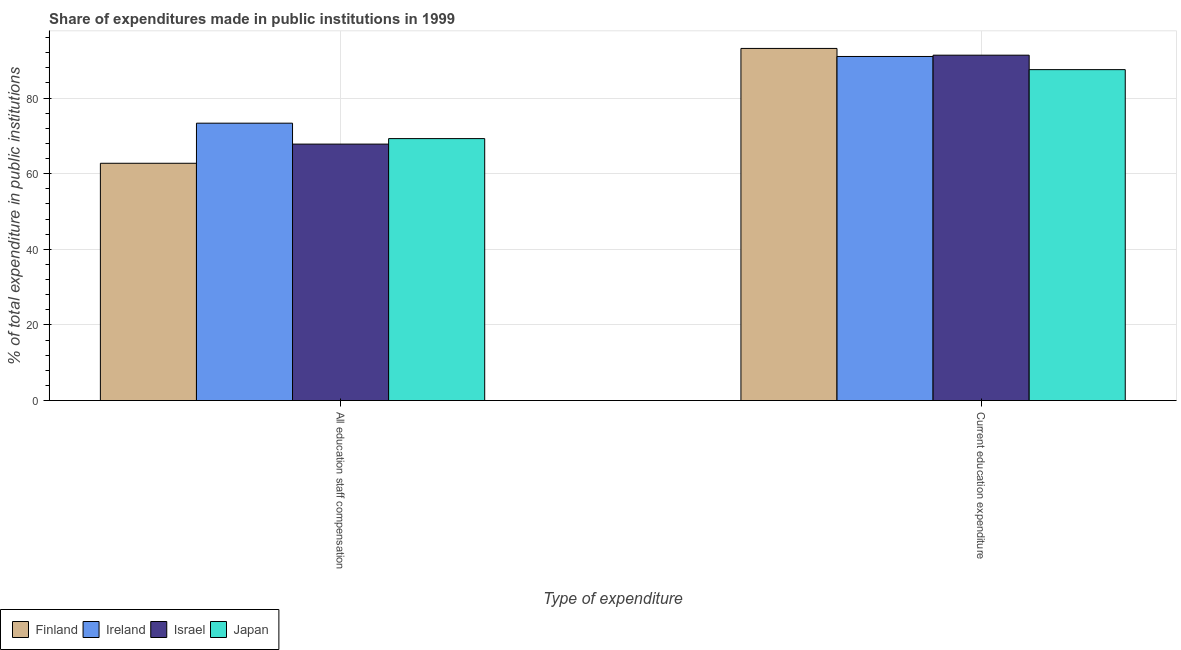Are the number of bars on each tick of the X-axis equal?
Make the answer very short. Yes. How many bars are there on the 2nd tick from the right?
Offer a very short reply. 4. What is the label of the 1st group of bars from the left?
Offer a terse response. All education staff compensation. What is the expenditure in education in Ireland?
Provide a succinct answer. 90.98. Across all countries, what is the maximum expenditure in staff compensation?
Your answer should be compact. 73.35. Across all countries, what is the minimum expenditure in staff compensation?
Offer a very short reply. 62.74. In which country was the expenditure in staff compensation maximum?
Offer a very short reply. Ireland. What is the total expenditure in staff compensation in the graph?
Offer a very short reply. 273.17. What is the difference between the expenditure in staff compensation in Ireland and that in Japan?
Your answer should be very brief. 4.08. What is the difference between the expenditure in staff compensation in Finland and the expenditure in education in Ireland?
Ensure brevity in your answer.  -28.24. What is the average expenditure in education per country?
Provide a succinct answer. 90.73. What is the difference between the expenditure in education and expenditure in staff compensation in Finland?
Offer a terse response. 30.37. In how many countries, is the expenditure in staff compensation greater than 24 %?
Offer a very short reply. 4. What is the ratio of the expenditure in staff compensation in Finland to that in Israel?
Ensure brevity in your answer.  0.93. Is the expenditure in staff compensation in Israel less than that in Ireland?
Your answer should be compact. Yes. In how many countries, is the expenditure in education greater than the average expenditure in education taken over all countries?
Offer a very short reply. 3. What does the 1st bar from the right in Current education expenditure represents?
Offer a very short reply. Japan. How many bars are there?
Ensure brevity in your answer.  8. Are all the bars in the graph horizontal?
Your response must be concise. No. How many countries are there in the graph?
Offer a terse response. 4. What is the difference between two consecutive major ticks on the Y-axis?
Keep it short and to the point. 20. Are the values on the major ticks of Y-axis written in scientific E-notation?
Your response must be concise. No. How are the legend labels stacked?
Provide a succinct answer. Horizontal. What is the title of the graph?
Ensure brevity in your answer.  Share of expenditures made in public institutions in 1999. Does "Timor-Leste" appear as one of the legend labels in the graph?
Offer a very short reply. No. What is the label or title of the X-axis?
Offer a very short reply. Type of expenditure. What is the label or title of the Y-axis?
Make the answer very short. % of total expenditure in public institutions. What is the % of total expenditure in public institutions in Finland in All education staff compensation?
Your answer should be compact. 62.74. What is the % of total expenditure in public institutions of Ireland in All education staff compensation?
Your answer should be compact. 73.35. What is the % of total expenditure in public institutions in Israel in All education staff compensation?
Provide a short and direct response. 67.81. What is the % of total expenditure in public institutions in Japan in All education staff compensation?
Provide a short and direct response. 69.27. What is the % of total expenditure in public institutions in Finland in Current education expenditure?
Keep it short and to the point. 93.11. What is the % of total expenditure in public institutions of Ireland in Current education expenditure?
Provide a short and direct response. 90.98. What is the % of total expenditure in public institutions of Israel in Current education expenditure?
Provide a succinct answer. 91.33. What is the % of total expenditure in public institutions in Japan in Current education expenditure?
Provide a short and direct response. 87.51. Across all Type of expenditure, what is the maximum % of total expenditure in public institutions in Finland?
Provide a succinct answer. 93.11. Across all Type of expenditure, what is the maximum % of total expenditure in public institutions of Ireland?
Offer a terse response. 90.98. Across all Type of expenditure, what is the maximum % of total expenditure in public institutions of Israel?
Your response must be concise. 91.33. Across all Type of expenditure, what is the maximum % of total expenditure in public institutions of Japan?
Your response must be concise. 87.51. Across all Type of expenditure, what is the minimum % of total expenditure in public institutions of Finland?
Give a very brief answer. 62.74. Across all Type of expenditure, what is the minimum % of total expenditure in public institutions in Ireland?
Keep it short and to the point. 73.35. Across all Type of expenditure, what is the minimum % of total expenditure in public institutions of Israel?
Keep it short and to the point. 67.81. Across all Type of expenditure, what is the minimum % of total expenditure in public institutions of Japan?
Your answer should be very brief. 69.27. What is the total % of total expenditure in public institutions in Finland in the graph?
Your response must be concise. 155.85. What is the total % of total expenditure in public institutions in Ireland in the graph?
Make the answer very short. 164.33. What is the total % of total expenditure in public institutions in Israel in the graph?
Your response must be concise. 159.14. What is the total % of total expenditure in public institutions in Japan in the graph?
Provide a succinct answer. 156.77. What is the difference between the % of total expenditure in public institutions of Finland in All education staff compensation and that in Current education expenditure?
Provide a short and direct response. -30.37. What is the difference between the % of total expenditure in public institutions of Ireland in All education staff compensation and that in Current education expenditure?
Offer a very short reply. -17.64. What is the difference between the % of total expenditure in public institutions in Israel in All education staff compensation and that in Current education expenditure?
Provide a short and direct response. -23.51. What is the difference between the % of total expenditure in public institutions of Japan in All education staff compensation and that in Current education expenditure?
Provide a short and direct response. -18.24. What is the difference between the % of total expenditure in public institutions in Finland in All education staff compensation and the % of total expenditure in public institutions in Ireland in Current education expenditure?
Offer a very short reply. -28.24. What is the difference between the % of total expenditure in public institutions of Finland in All education staff compensation and the % of total expenditure in public institutions of Israel in Current education expenditure?
Offer a terse response. -28.58. What is the difference between the % of total expenditure in public institutions in Finland in All education staff compensation and the % of total expenditure in public institutions in Japan in Current education expenditure?
Keep it short and to the point. -24.76. What is the difference between the % of total expenditure in public institutions in Ireland in All education staff compensation and the % of total expenditure in public institutions in Israel in Current education expenditure?
Give a very brief answer. -17.98. What is the difference between the % of total expenditure in public institutions in Ireland in All education staff compensation and the % of total expenditure in public institutions in Japan in Current education expenditure?
Your answer should be compact. -14.16. What is the difference between the % of total expenditure in public institutions of Israel in All education staff compensation and the % of total expenditure in public institutions of Japan in Current education expenditure?
Ensure brevity in your answer.  -19.69. What is the average % of total expenditure in public institutions of Finland per Type of expenditure?
Your answer should be compact. 77.93. What is the average % of total expenditure in public institutions in Ireland per Type of expenditure?
Provide a succinct answer. 82.17. What is the average % of total expenditure in public institutions in Israel per Type of expenditure?
Give a very brief answer. 79.57. What is the average % of total expenditure in public institutions in Japan per Type of expenditure?
Keep it short and to the point. 78.39. What is the difference between the % of total expenditure in public institutions in Finland and % of total expenditure in public institutions in Ireland in All education staff compensation?
Your answer should be very brief. -10.6. What is the difference between the % of total expenditure in public institutions in Finland and % of total expenditure in public institutions in Israel in All education staff compensation?
Keep it short and to the point. -5.07. What is the difference between the % of total expenditure in public institutions in Finland and % of total expenditure in public institutions in Japan in All education staff compensation?
Make the answer very short. -6.52. What is the difference between the % of total expenditure in public institutions of Ireland and % of total expenditure in public institutions of Israel in All education staff compensation?
Offer a very short reply. 5.53. What is the difference between the % of total expenditure in public institutions of Ireland and % of total expenditure in public institutions of Japan in All education staff compensation?
Give a very brief answer. 4.08. What is the difference between the % of total expenditure in public institutions of Israel and % of total expenditure in public institutions of Japan in All education staff compensation?
Provide a short and direct response. -1.45. What is the difference between the % of total expenditure in public institutions in Finland and % of total expenditure in public institutions in Ireland in Current education expenditure?
Keep it short and to the point. 2.13. What is the difference between the % of total expenditure in public institutions of Finland and % of total expenditure in public institutions of Israel in Current education expenditure?
Offer a very short reply. 1.78. What is the difference between the % of total expenditure in public institutions of Finland and % of total expenditure in public institutions of Japan in Current education expenditure?
Provide a succinct answer. 5.6. What is the difference between the % of total expenditure in public institutions of Ireland and % of total expenditure in public institutions of Israel in Current education expenditure?
Keep it short and to the point. -0.34. What is the difference between the % of total expenditure in public institutions of Ireland and % of total expenditure in public institutions of Japan in Current education expenditure?
Provide a succinct answer. 3.48. What is the difference between the % of total expenditure in public institutions in Israel and % of total expenditure in public institutions in Japan in Current education expenditure?
Provide a succinct answer. 3.82. What is the ratio of the % of total expenditure in public institutions in Finland in All education staff compensation to that in Current education expenditure?
Offer a very short reply. 0.67. What is the ratio of the % of total expenditure in public institutions of Ireland in All education staff compensation to that in Current education expenditure?
Ensure brevity in your answer.  0.81. What is the ratio of the % of total expenditure in public institutions of Israel in All education staff compensation to that in Current education expenditure?
Ensure brevity in your answer.  0.74. What is the ratio of the % of total expenditure in public institutions in Japan in All education staff compensation to that in Current education expenditure?
Your answer should be very brief. 0.79. What is the difference between the highest and the second highest % of total expenditure in public institutions of Finland?
Ensure brevity in your answer.  30.37. What is the difference between the highest and the second highest % of total expenditure in public institutions in Ireland?
Provide a short and direct response. 17.64. What is the difference between the highest and the second highest % of total expenditure in public institutions in Israel?
Offer a terse response. 23.51. What is the difference between the highest and the second highest % of total expenditure in public institutions in Japan?
Provide a succinct answer. 18.24. What is the difference between the highest and the lowest % of total expenditure in public institutions of Finland?
Your response must be concise. 30.37. What is the difference between the highest and the lowest % of total expenditure in public institutions of Ireland?
Your answer should be very brief. 17.64. What is the difference between the highest and the lowest % of total expenditure in public institutions in Israel?
Make the answer very short. 23.51. What is the difference between the highest and the lowest % of total expenditure in public institutions of Japan?
Your answer should be very brief. 18.24. 